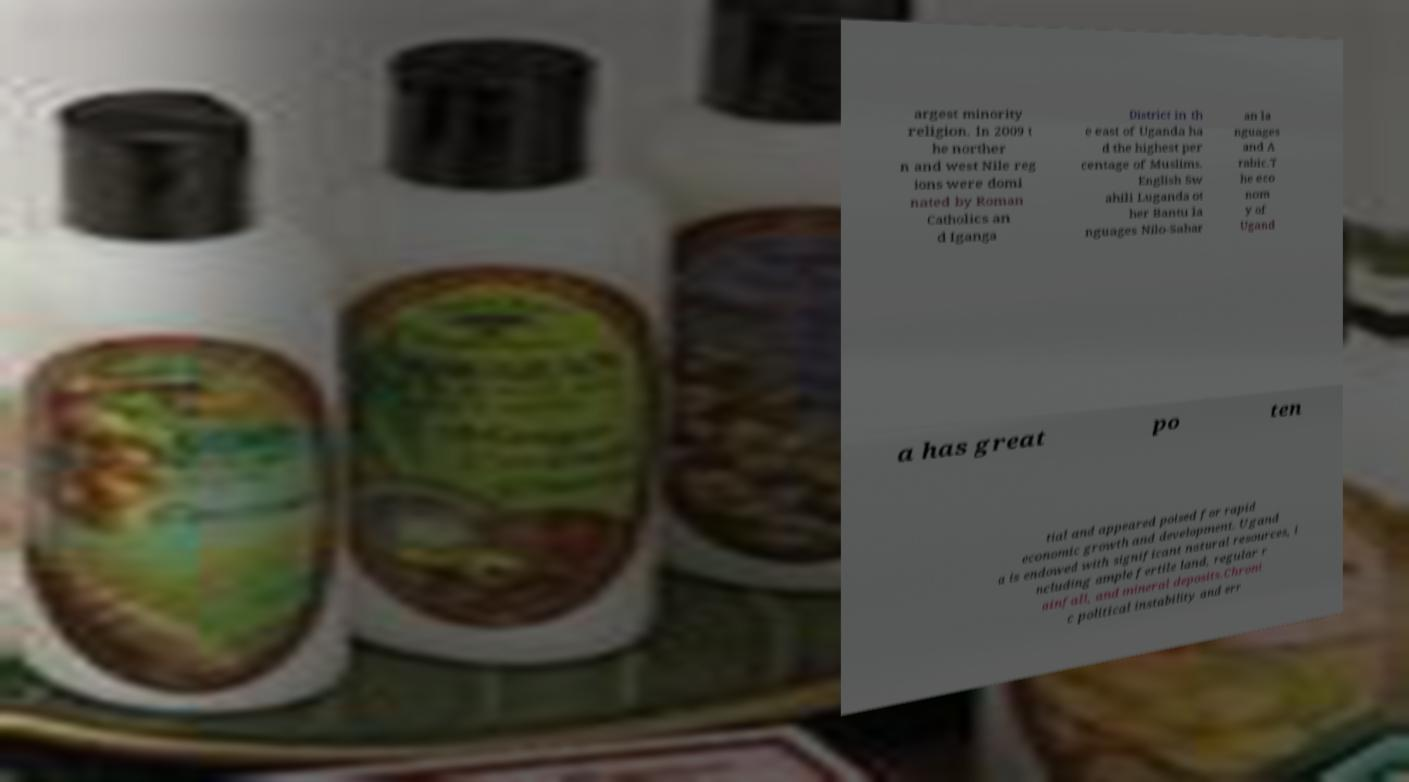I need the written content from this picture converted into text. Can you do that? argest minority religion. In 2009 t he norther n and west Nile reg ions were domi nated by Roman Catholics an d Iganga District in th e east of Uganda ha d the highest per centage of Muslims. English Sw ahili Luganda ot her Bantu la nguages Nilo-Sahar an la nguages and A rabic.T he eco nom y of Ugand a has great po ten tial and appeared poised for rapid economic growth and development. Ugand a is endowed with significant natural resources, i ncluding ample fertile land, regular r ainfall, and mineral deposits.Chroni c political instability and err 